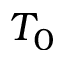<formula> <loc_0><loc_0><loc_500><loc_500>T _ { 0 }</formula> 